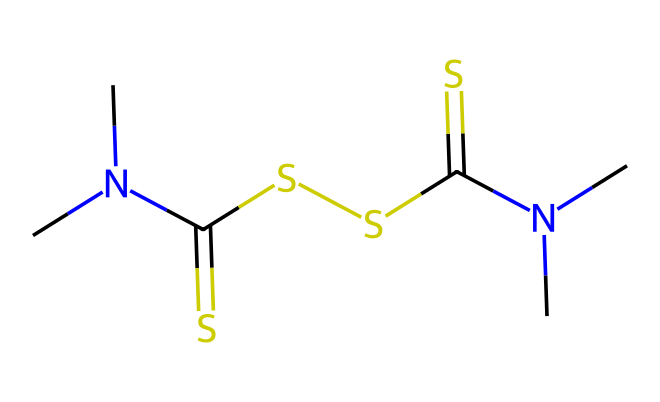how many nitrogen atoms are in thiram? The SMILES representation contains two nitrogen atoms denoted by "N". By counting the occurrences of "N" in the structure, we find that there are exactly two nitrogen atoms.
Answer: two how many carbon atoms are in thiram? Looking at the SMILES representation, "C" appears five times, indicating that there are five carbon atoms in thiram.
Answer: five what type of chemical structure is thiram? Thiram is identified as a dithiocarbamate based on its molecular structure, which has dithiocarbamate characteristics.
Answer: dithiocarbamate what is the total number of sulfur atoms in thiram? In the SMILES, "S" appears three times, meaning there are three sulfur atoms present in the thiram structure.
Answer: three what functional group is primarily responsible for thiram's fungicidal activity? The presence of the dithiocarbamate functional group (indicated by the "C(=S)" portions in the structure) is primarily responsible for thiram's fungicidal activity.
Answer: dithiocarbamate what is the molecular formula of thiram based on the SMILES? From analyzing the number of each type of atom present in the SMILES, we can deduce the molecular formula as C6H12N2S3.
Answer: C6H12N2S3 how many methyl groups are in thiram? The presence of "N(C)C" indicates two methyl groups attached to each nitrogen atom, resulting in a total of four methyl groups in the structure.
Answer: four 